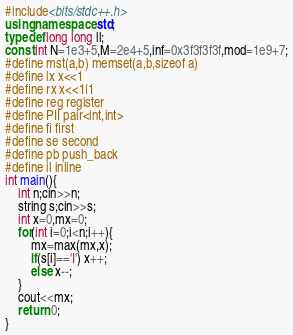Convert code to text. <code><loc_0><loc_0><loc_500><loc_500><_C++_>#include<bits/stdc++.h>
using namespace std;
typedef long long ll;
const int N=1e3+5,M=2e4+5,inf=0x3f3f3f3f,mod=1e9+7;
#define mst(a,b) memset(a,b,sizeof a)
#define lx x<<1
#define rx x<<1|1
#define reg register
#define PII pair<int,int>
#define fi first
#define se second
#define pb push_back
#define il inline
int main(){
	int n;cin>>n; 
	string s;cin>>s;
	int x=0,mx=0;
	for(int i=0;i<n;i++){
		mx=max(mx,x);
		if(s[i]=='I') x++;
		else x--;
	}
	cout<<mx;
	return 0;
}</code> 